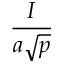Convert formula to latex. <formula><loc_0><loc_0><loc_500><loc_500>\frac { I } { a { \sqrt { p } } }</formula> 